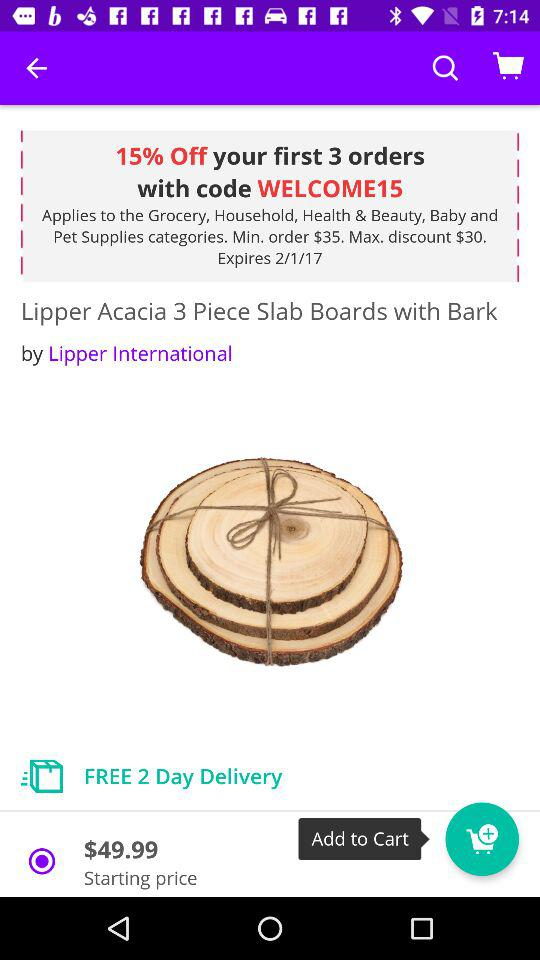What is the starting price of the product? The starting price of the product is $49.99. 